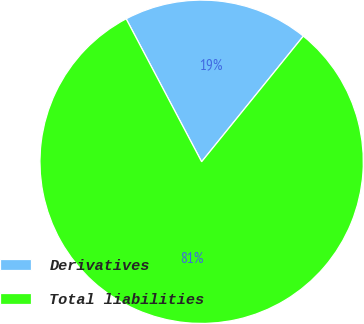<chart> <loc_0><loc_0><loc_500><loc_500><pie_chart><fcel>Derivatives<fcel>Total liabilities<nl><fcel>18.56%<fcel>81.44%<nl></chart> 